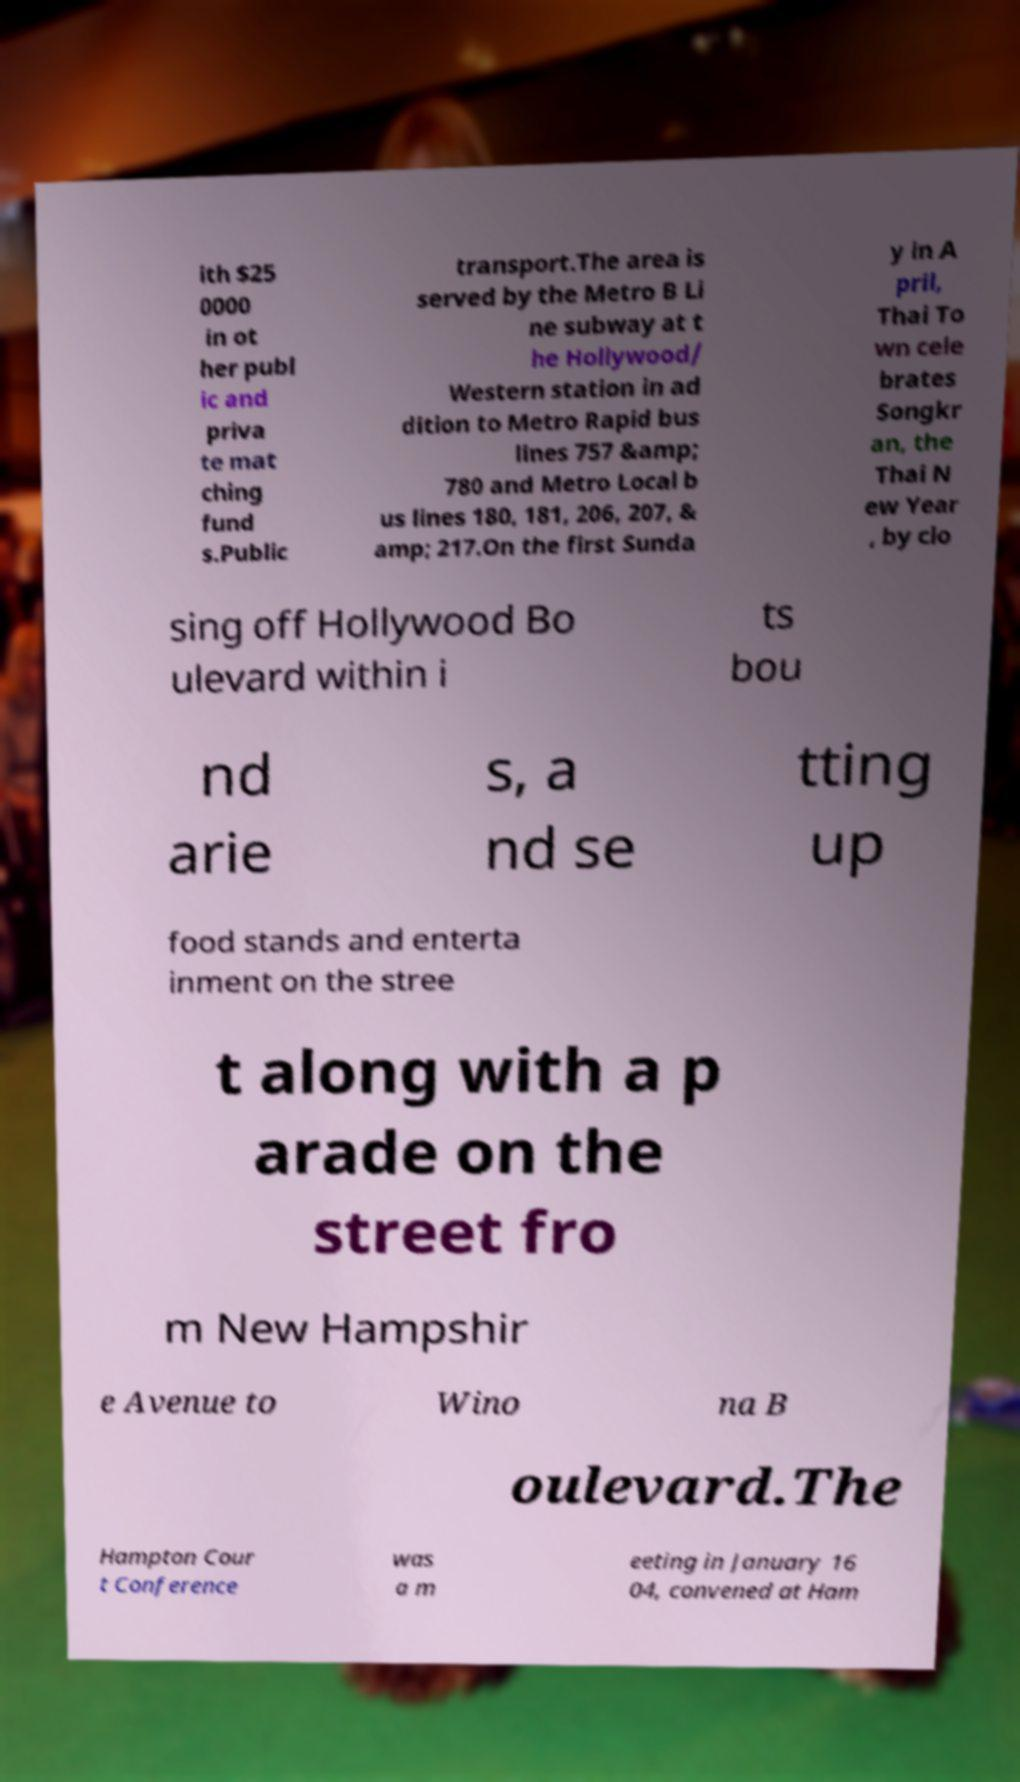Could you assist in decoding the text presented in this image and type it out clearly? ith $25 0000 in ot her publ ic and priva te mat ching fund s.Public transport.The area is served by the Metro B Li ne subway at t he Hollywood/ Western station in ad dition to Metro Rapid bus lines 757 &amp; 780 and Metro Local b us lines 180, 181, 206, 207, & amp; 217.On the first Sunda y in A pril, Thai To wn cele brates Songkr an, the Thai N ew Year , by clo sing off Hollywood Bo ulevard within i ts bou nd arie s, a nd se tting up food stands and enterta inment on the stree t along with a p arade on the street fro m New Hampshir e Avenue to Wino na B oulevard.The Hampton Cour t Conference was a m eeting in January 16 04, convened at Ham 